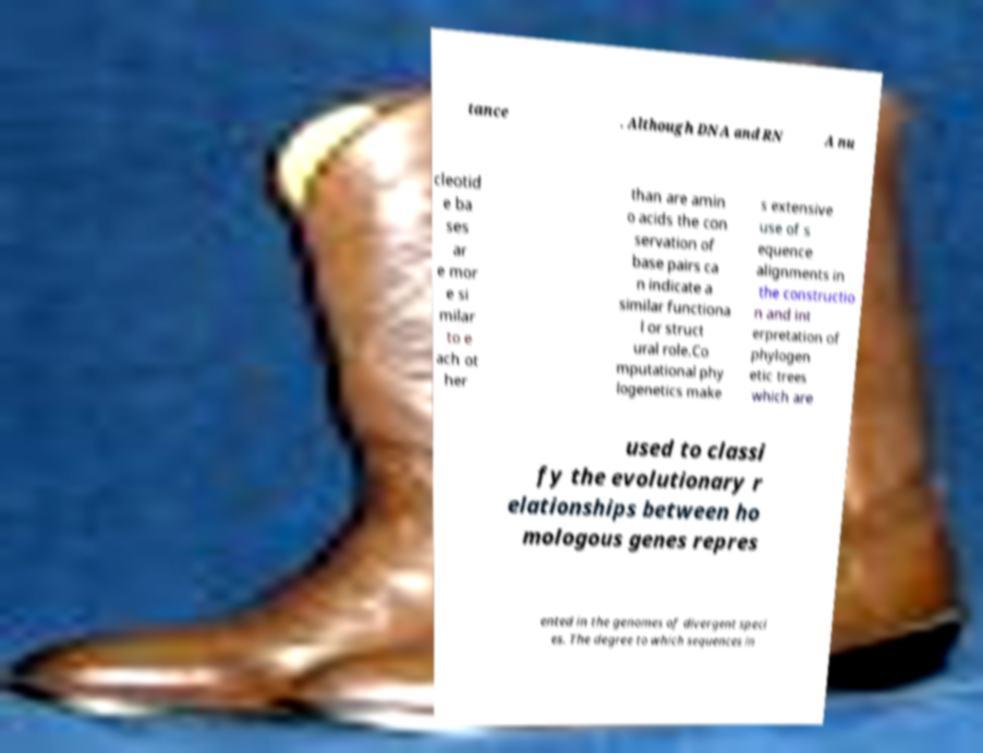What messages or text are displayed in this image? I need them in a readable, typed format. tance . Although DNA and RN A nu cleotid e ba ses ar e mor e si milar to e ach ot her than are amin o acids the con servation of base pairs ca n indicate a similar functiona l or struct ural role.Co mputational phy logenetics make s extensive use of s equence alignments in the constructio n and int erpretation of phylogen etic trees which are used to classi fy the evolutionary r elationships between ho mologous genes repres ented in the genomes of divergent speci es. The degree to which sequences in 